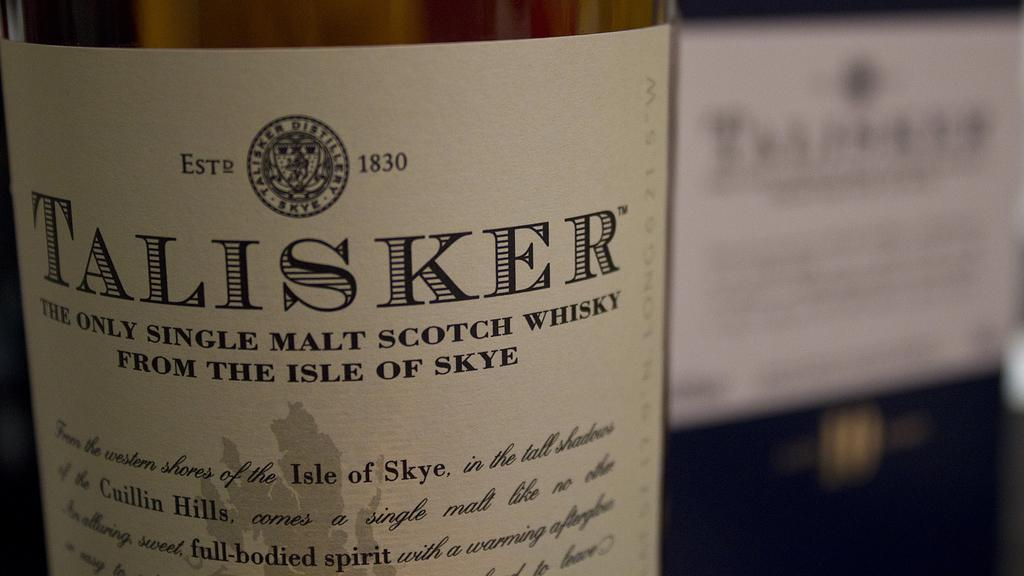<image>
Relay a brief, clear account of the picture shown. A bottle of Talisker malt scotch whisky from the isle of Skye. 